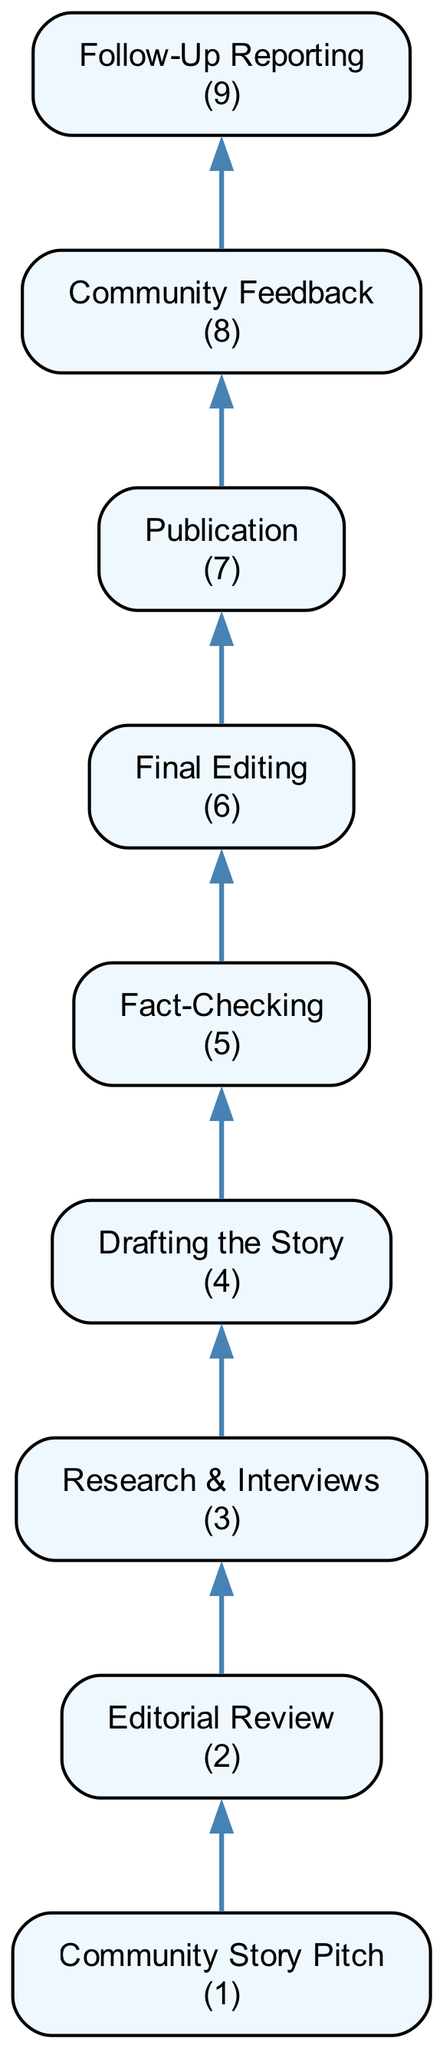What's the first step in the workflow? The diagram shows that the first step in the workflow is "Community Story Pitch," which involves generating initial ideas about local issues, events, or concerns.
Answer: Community Story Pitch How many steps are there in the diagram? There are 9 steps illustrated in the diagram, from the "Community Story Pitch" to "Follow-Up Reporting."
Answer: 9 What is the last step before publication? The last step before publication is "Final Editing," where the editor reviews the draft for clarity and grammar.
Answer: Final Editing Which step follows "Fact-Checking"? The step that directly follows "Fact-Checking" is "Final Editing," indicating the process moves from verifying information to refining the written draft.
Answer: Final Editing What type of feedback is collected after publication? After publication, the feedback collected is referred to as "Community Feedback," assessing the story's impact through reader interactions and engagement metrics.
Answer: Community Feedback What is the relationship between "Community Story Pitch" and "Follow-Up Reporting"? The relationship is sequential; "Community Story Pitch" initiates the workflow, leading to other steps, including "Follow-Up Reporting," which builds on community feedback and ongoing developments.
Answer: Sequential How does the editorial review impact the story? The "Editorial Review" step impacts the story by evaluating its relevance and newsworthiness, determining which pitches proceed to research and development.
Answer: Evaluates relevance What are the two steps that directly precede "Publication"? The two steps that directly precede "Publication" are "Final Editing" and "Fact-Checking," both crucial for ensuring accuracy and flow before the story goes live.
Answer: Final Editing, Fact-Checking Why is "Research & Interviews" important in this workflow? "Research & Interviews" is important because it gathers essential information from local stakeholders and experts, forming the foundation of a credible news article.
Answer: Essential information gathering 